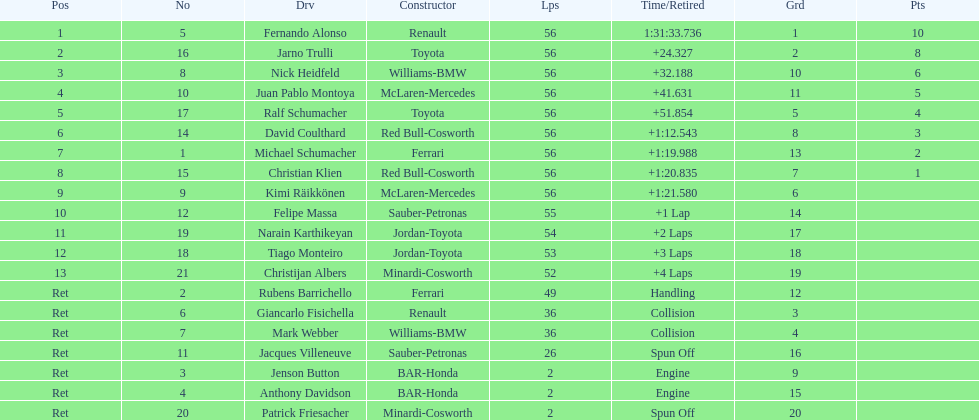Who was the last driver from the uk to actually finish the 56 laps? David Coulthard. 